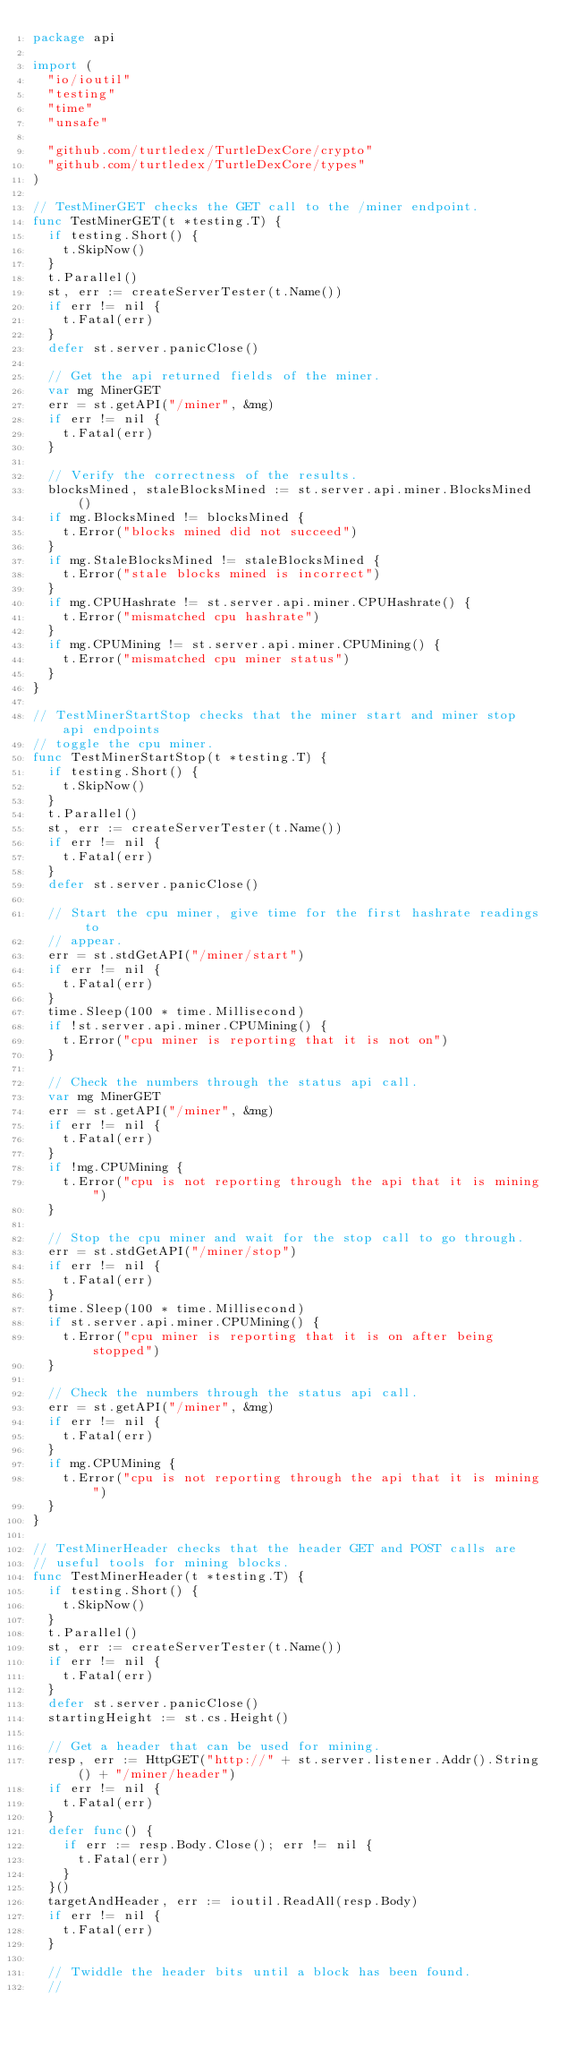<code> <loc_0><loc_0><loc_500><loc_500><_Go_>package api

import (
	"io/ioutil"
	"testing"
	"time"
	"unsafe"

	"github.com/turtledex/TurtleDexCore/crypto"
	"github.com/turtledex/TurtleDexCore/types"
)

// TestMinerGET checks the GET call to the /miner endpoint.
func TestMinerGET(t *testing.T) {
	if testing.Short() {
		t.SkipNow()
	}
	t.Parallel()
	st, err := createServerTester(t.Name())
	if err != nil {
		t.Fatal(err)
	}
	defer st.server.panicClose()

	// Get the api returned fields of the miner.
	var mg MinerGET
	err = st.getAPI("/miner", &mg)
	if err != nil {
		t.Fatal(err)
	}

	// Verify the correctness of the results.
	blocksMined, staleBlocksMined := st.server.api.miner.BlocksMined()
	if mg.BlocksMined != blocksMined {
		t.Error("blocks mined did not succeed")
	}
	if mg.StaleBlocksMined != staleBlocksMined {
		t.Error("stale blocks mined is incorrect")
	}
	if mg.CPUHashrate != st.server.api.miner.CPUHashrate() {
		t.Error("mismatched cpu hashrate")
	}
	if mg.CPUMining != st.server.api.miner.CPUMining() {
		t.Error("mismatched cpu miner status")
	}
}

// TestMinerStartStop checks that the miner start and miner stop api endpoints
// toggle the cpu miner.
func TestMinerStartStop(t *testing.T) {
	if testing.Short() {
		t.SkipNow()
	}
	t.Parallel()
	st, err := createServerTester(t.Name())
	if err != nil {
		t.Fatal(err)
	}
	defer st.server.panicClose()

	// Start the cpu miner, give time for the first hashrate readings to
	// appear.
	err = st.stdGetAPI("/miner/start")
	if err != nil {
		t.Fatal(err)
	}
	time.Sleep(100 * time.Millisecond)
	if !st.server.api.miner.CPUMining() {
		t.Error("cpu miner is reporting that it is not on")
	}

	// Check the numbers through the status api call.
	var mg MinerGET
	err = st.getAPI("/miner", &mg)
	if err != nil {
		t.Fatal(err)
	}
	if !mg.CPUMining {
		t.Error("cpu is not reporting through the api that it is mining")
	}

	// Stop the cpu miner and wait for the stop call to go through.
	err = st.stdGetAPI("/miner/stop")
	if err != nil {
		t.Fatal(err)
	}
	time.Sleep(100 * time.Millisecond)
	if st.server.api.miner.CPUMining() {
		t.Error("cpu miner is reporting that it is on after being stopped")
	}

	// Check the numbers through the status api call.
	err = st.getAPI("/miner", &mg)
	if err != nil {
		t.Fatal(err)
	}
	if mg.CPUMining {
		t.Error("cpu is not reporting through the api that it is mining")
	}
}

// TestMinerHeader checks that the header GET and POST calls are
// useful tools for mining blocks.
func TestMinerHeader(t *testing.T) {
	if testing.Short() {
		t.SkipNow()
	}
	t.Parallel()
	st, err := createServerTester(t.Name())
	if err != nil {
		t.Fatal(err)
	}
	defer st.server.panicClose()
	startingHeight := st.cs.Height()

	// Get a header that can be used for mining.
	resp, err := HttpGET("http://" + st.server.listener.Addr().String() + "/miner/header")
	if err != nil {
		t.Fatal(err)
	}
	defer func() {
		if err := resp.Body.Close(); err != nil {
			t.Fatal(err)
		}
	}()
	targetAndHeader, err := ioutil.ReadAll(resp.Body)
	if err != nil {
		t.Fatal(err)
	}

	// Twiddle the header bits until a block has been found.
	//</code> 